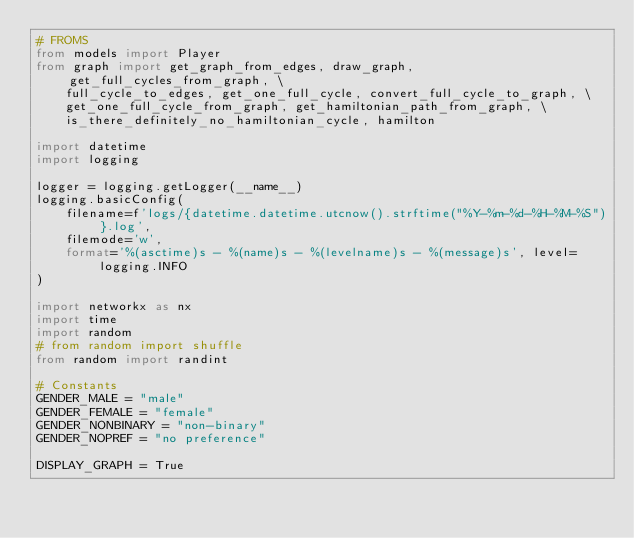Convert code to text. <code><loc_0><loc_0><loc_500><loc_500><_Python_># FROMS
from models import Player
from graph import get_graph_from_edges, draw_graph, get_full_cycles_from_graph, \
    full_cycle_to_edges, get_one_full_cycle, convert_full_cycle_to_graph, \
    get_one_full_cycle_from_graph, get_hamiltonian_path_from_graph, \
    is_there_definitely_no_hamiltonian_cycle, hamilton

import datetime
import logging

logger = logging.getLogger(__name__)
logging.basicConfig(
    filename=f'logs/{datetime.datetime.utcnow().strftime("%Y-%m-%d-%H-%M-%S")}.log',
    filemode='w',
    format='%(asctime)s - %(name)s - %(levelname)s - %(message)s', level=logging.INFO
)

import networkx as nx
import time
import random
# from random import shuffle
from random import randint

# Constants
GENDER_MALE = "male"
GENDER_FEMALE = "female"
GENDER_NONBINARY = "non-binary"
GENDER_NOPREF = "no preference"

DISPLAY_GRAPH = True
</code> 